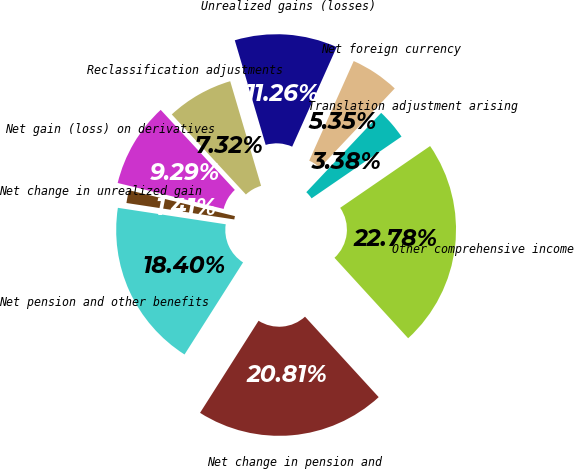Convert chart. <chart><loc_0><loc_0><loc_500><loc_500><pie_chart><fcel>Translation adjustment arising<fcel>Net foreign currency<fcel>Unrealized gains (losses)<fcel>Reclassification adjustments<fcel>Net gain (loss) on derivatives<fcel>Net change in unrealized gain<fcel>Net pension and other benefits<fcel>Net change in pension and<fcel>Other comprehensive income<nl><fcel>3.38%<fcel>5.35%<fcel>11.26%<fcel>7.32%<fcel>9.29%<fcel>1.41%<fcel>18.4%<fcel>20.81%<fcel>22.78%<nl></chart> 